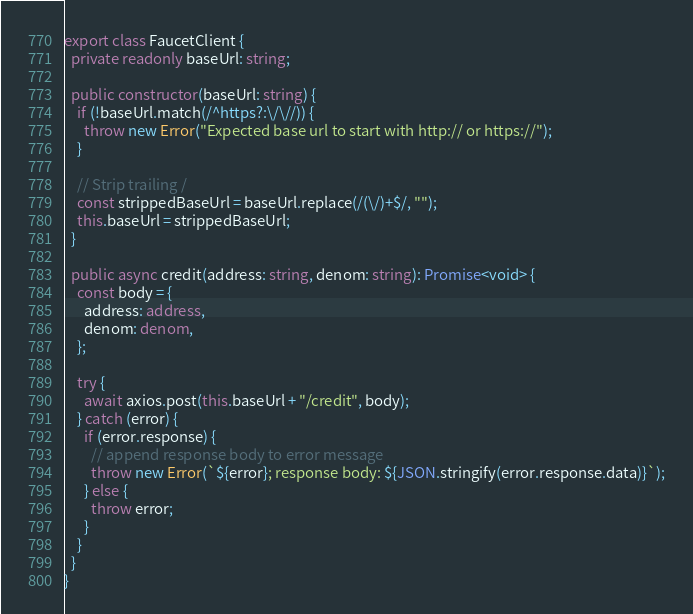<code> <loc_0><loc_0><loc_500><loc_500><_TypeScript_>
export class FaucetClient {
  private readonly baseUrl: string;

  public constructor(baseUrl: string) {
    if (!baseUrl.match(/^https?:\/\//)) {
      throw new Error("Expected base url to start with http:// or https://");
    }

    // Strip trailing /
    const strippedBaseUrl = baseUrl.replace(/(\/)+$/, "");
    this.baseUrl = strippedBaseUrl;
  }

  public async credit(address: string, denom: string): Promise<void> {
    const body = {
      address: address,
      denom: denom,
    };

    try {
      await axios.post(this.baseUrl + "/credit", body);
    } catch (error) {
      if (error.response) {
        // append response body to error message
        throw new Error(`${error}; response body: ${JSON.stringify(error.response.data)}`);
      } else {
        throw error;
      }
    }
  }
}
</code> 